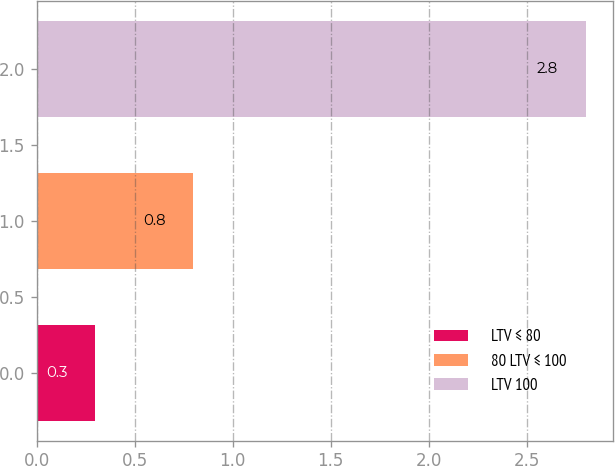Convert chart. <chart><loc_0><loc_0><loc_500><loc_500><bar_chart><fcel>LTV ≤ 80<fcel>80 LTV ≤ 100<fcel>LTV 100<nl><fcel>0.3<fcel>0.8<fcel>2.8<nl></chart> 